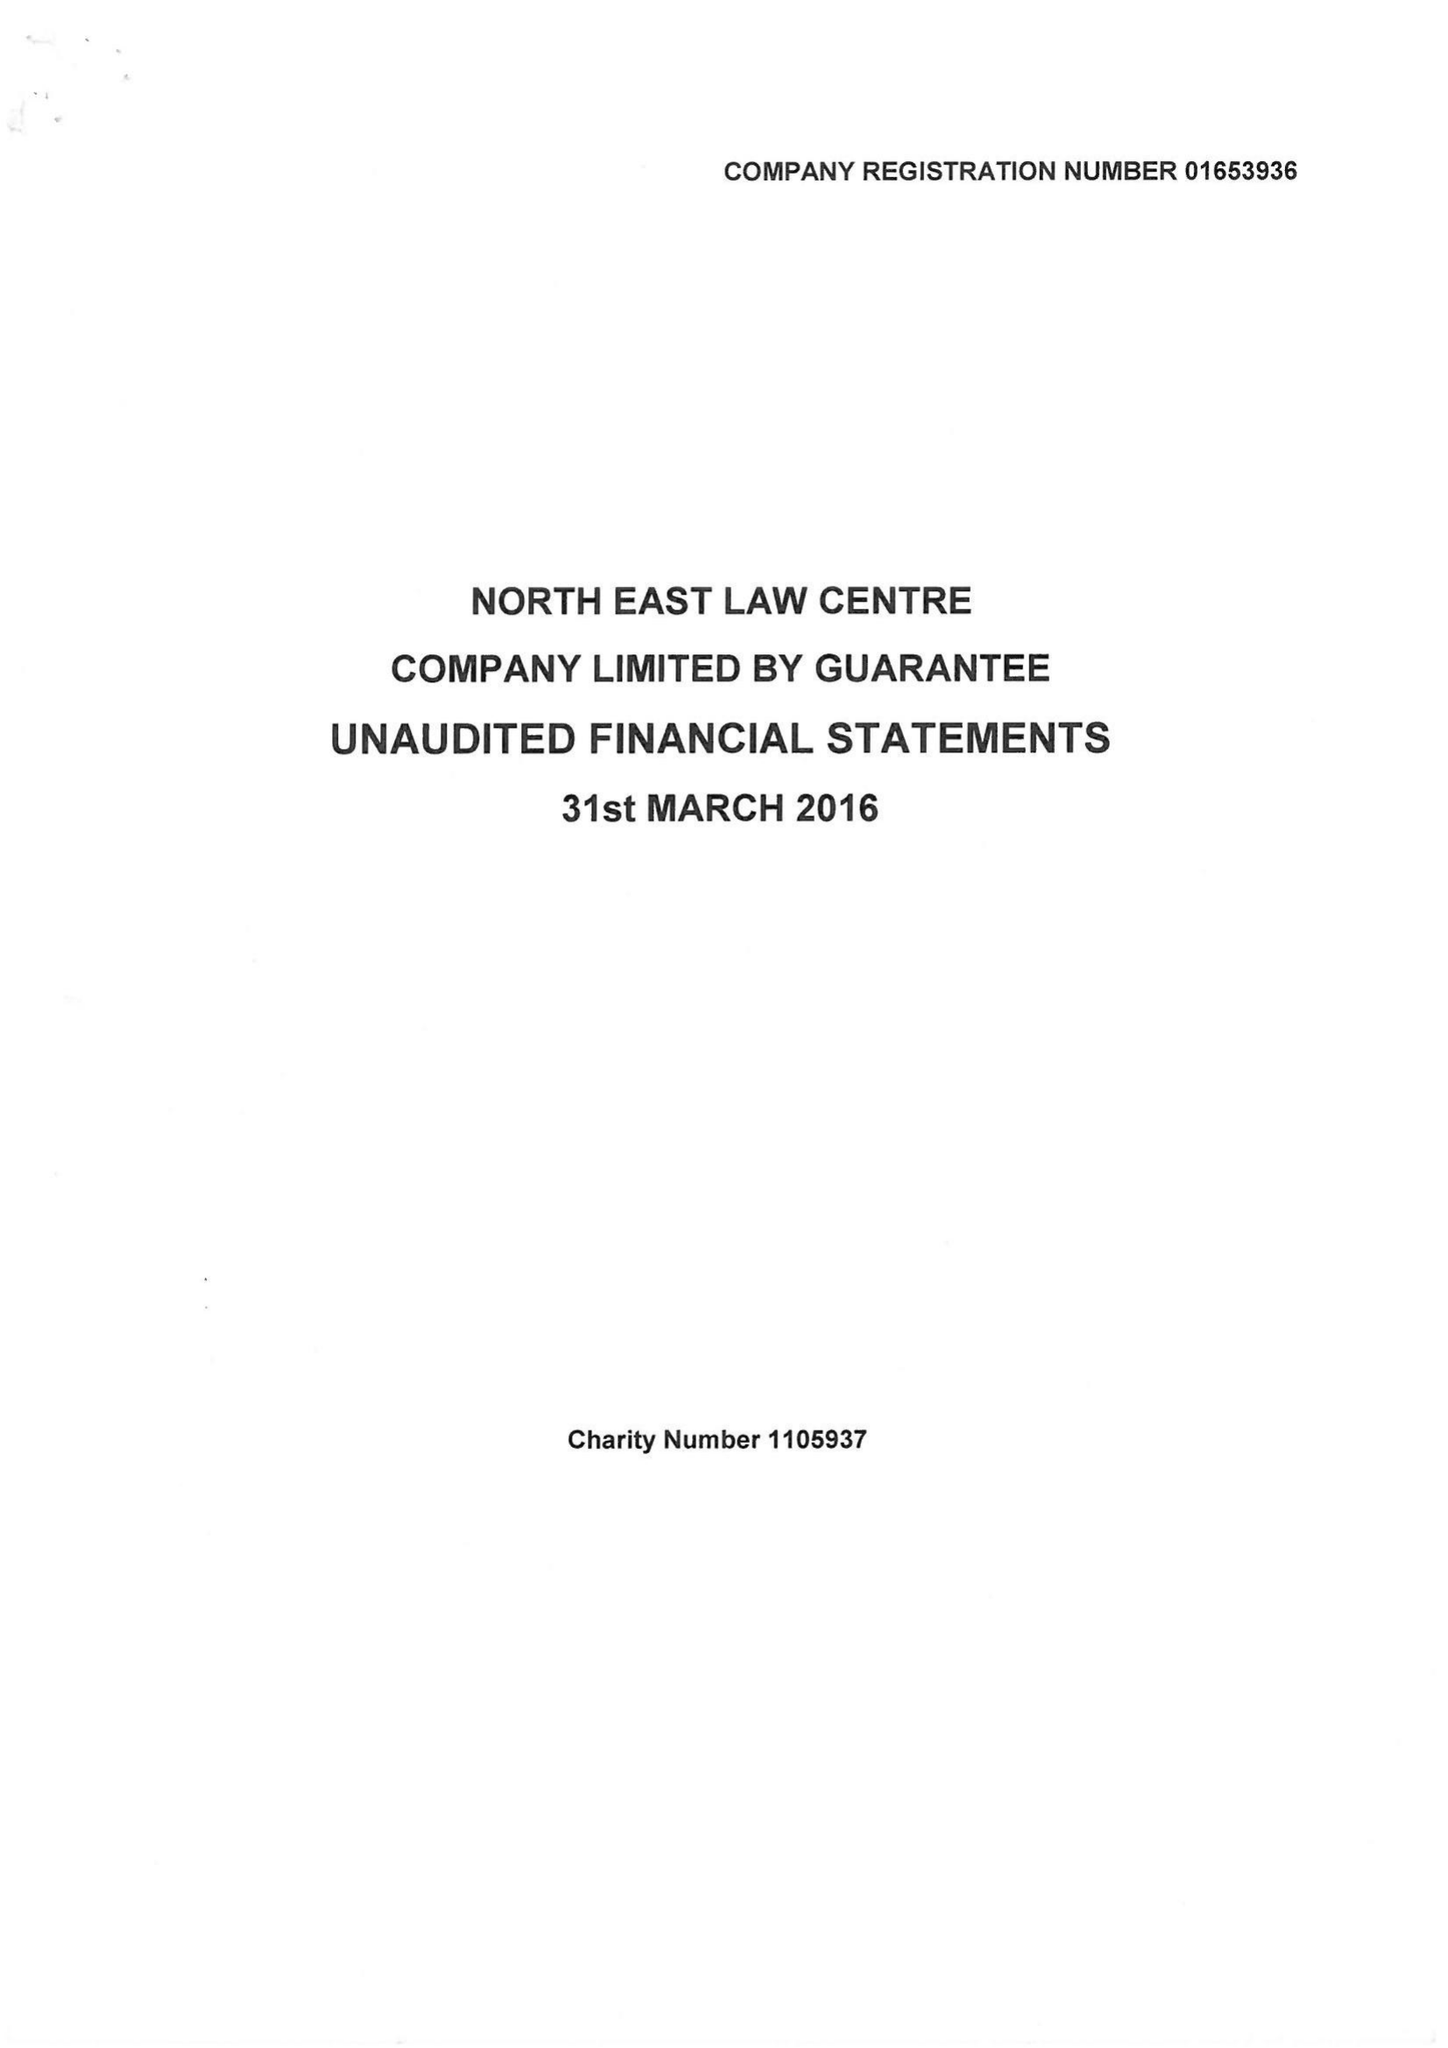What is the value for the income_annually_in_british_pounds?
Answer the question using a single word or phrase. 268839.00 